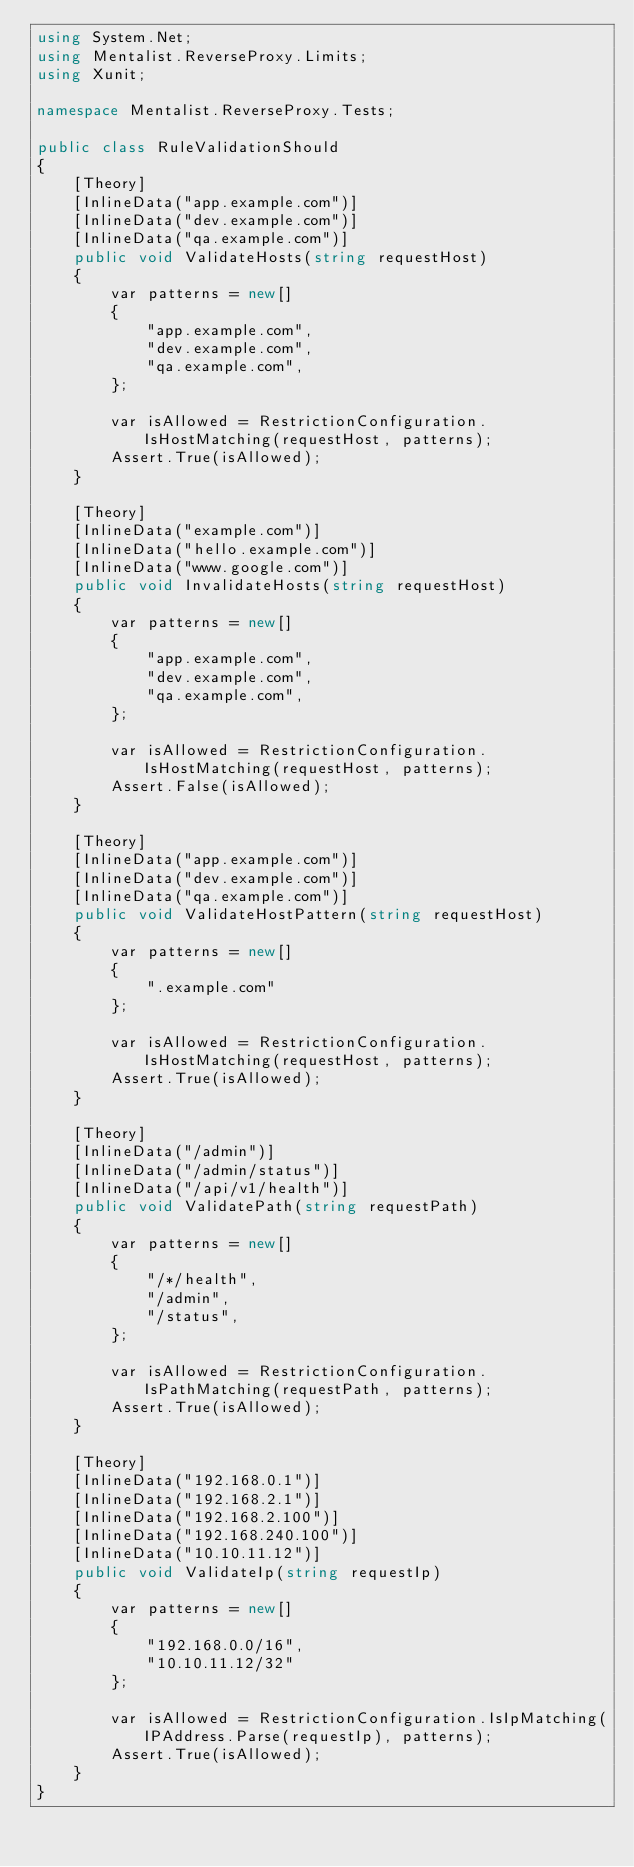<code> <loc_0><loc_0><loc_500><loc_500><_C#_>using System.Net;
using Mentalist.ReverseProxy.Limits;
using Xunit;

namespace Mentalist.ReverseProxy.Tests;

public class RuleValidationShould
{
    [Theory]
    [InlineData("app.example.com")]
    [InlineData("dev.example.com")]
    [InlineData("qa.example.com")]
    public void ValidateHosts(string requestHost)
    {
        var patterns = new[]
        {
            "app.example.com",
            "dev.example.com",
            "qa.example.com",
        };

        var isAllowed = RestrictionConfiguration.IsHostMatching(requestHost, patterns);
        Assert.True(isAllowed);
    }

    [Theory]
    [InlineData("example.com")]
    [InlineData("hello.example.com")]
    [InlineData("www.google.com")]
    public void InvalidateHosts(string requestHost)
    {
        var patterns = new[]
        {
            "app.example.com",
            "dev.example.com",
            "qa.example.com",
        };

        var isAllowed = RestrictionConfiguration.IsHostMatching(requestHost, patterns);
        Assert.False(isAllowed);
    }

    [Theory]
    [InlineData("app.example.com")]
    [InlineData("dev.example.com")]
    [InlineData("qa.example.com")]
    public void ValidateHostPattern(string requestHost)
    {
        var patterns = new[]
        {
            ".example.com"
        };

        var isAllowed = RestrictionConfiguration.IsHostMatching(requestHost, patterns);
        Assert.True(isAllowed);
    }

    [Theory]
    [InlineData("/admin")]
    [InlineData("/admin/status")]
    [InlineData("/api/v1/health")]
    public void ValidatePath(string requestPath)
    {
        var patterns = new[]
        {
            "/*/health",
            "/admin",
            "/status",
        };

        var isAllowed = RestrictionConfiguration.IsPathMatching(requestPath, patterns);
        Assert.True(isAllowed);
    }

    [Theory]
    [InlineData("192.168.0.1")]
    [InlineData("192.168.2.1")]
    [InlineData("192.168.2.100")]
    [InlineData("192.168.240.100")]
    [InlineData("10.10.11.12")]
    public void ValidateIp(string requestIp)
    {
        var patterns = new[]
        {
            "192.168.0.0/16",
            "10.10.11.12/32"
        };

        var isAllowed = RestrictionConfiguration.IsIpMatching(IPAddress.Parse(requestIp), patterns);
        Assert.True(isAllowed);
    }
}</code> 